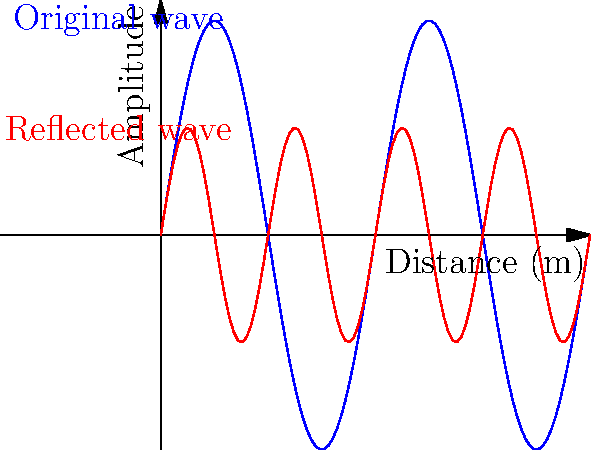In your low-budget film studio, you're struggling with sound reflections. The graph shows an original sound wave (blue) and its reflection (red) from a wall. If the original wave has a frequency of 440 Hz, what is the frequency of the reflected wave, and how might this affect your audio recording? Let's approach this step-by-step:

1) First, observe the graph. The blue line represents the original wave, and the red line represents the reflected wave.

2) Count the number of complete cycles for each wave within the same distance:
   - Original wave (blue): 2 complete cycles
   - Reflected wave (red): 4 complete cycles

3) This means the reflected wave has twice the frequency of the original wave.

4) We're given that the original wave has a frequency of 440 Hz.

5) To calculate the frequency of the reflected wave:
   $f_{reflected} = 2 \times f_{original} = 2 \times 440 \text{ Hz} = 880 \text{ Hz}$

6) Effect on audio recording:
   - This doubling of frequency is known as the second harmonic.
   - It can create a richer, more complex sound, but may also lead to unwanted resonance or echo.
   - In a small, untreated studio, this could result in a 'boxy' or 'ringy' sound quality.
   - It might particularly affect vocals and instruments in the mid-range frequencies.

7) For a low-budget filmmaker, this could present challenges in achieving clean, professional-sounding dialogue or music recordings without proper acoustic treatment.
Answer: 880 Hz; may cause unwanted resonance or 'boxy' sound quality. 